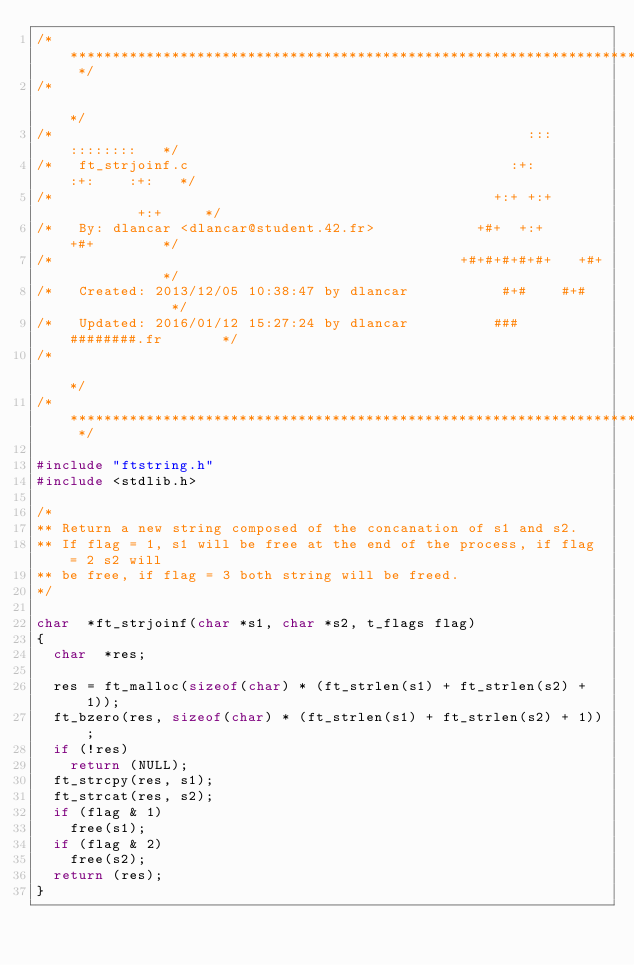<code> <loc_0><loc_0><loc_500><loc_500><_C_>/* ************************************************************************** */
/*                                                                            */
/*                                                        :::      ::::::::   */
/*   ft_strjoinf.c                                      :+:      :+:    :+:   */
/*                                                    +:+ +:+         +:+     */
/*   By: dlancar <dlancar@student.42.fr>            +#+  +:+       +#+        */
/*                                                +#+#+#+#+#+   +#+           */
/*   Created: 2013/12/05 10:38:47 by dlancar           #+#    #+#             */
/*   Updated: 2016/01/12 15:27:24 by dlancar          ###   ########.fr       */
/*                                                                            */
/* ************************************************************************** */

#include "ftstring.h"
#include <stdlib.h>

/*
** Return a new string composed of the concanation of s1 and s2.
** If flag = 1, s1 will be free at the end of the process, if flag = 2 s2 will
** be free, if flag = 3 both string will be freed.
*/

char	*ft_strjoinf(char *s1, char *s2, t_flags flag)
{
	char	*res;

	res = ft_malloc(sizeof(char) * (ft_strlen(s1) + ft_strlen(s2) + 1));
	ft_bzero(res, sizeof(char) * (ft_strlen(s1) + ft_strlen(s2) + 1));
	if (!res)
		return (NULL);
	ft_strcpy(res, s1);
	ft_strcat(res, s2);
	if (flag & 1)
		free(s1);
	if (flag & 2)
		free(s2);
	return (res);
}
</code> 